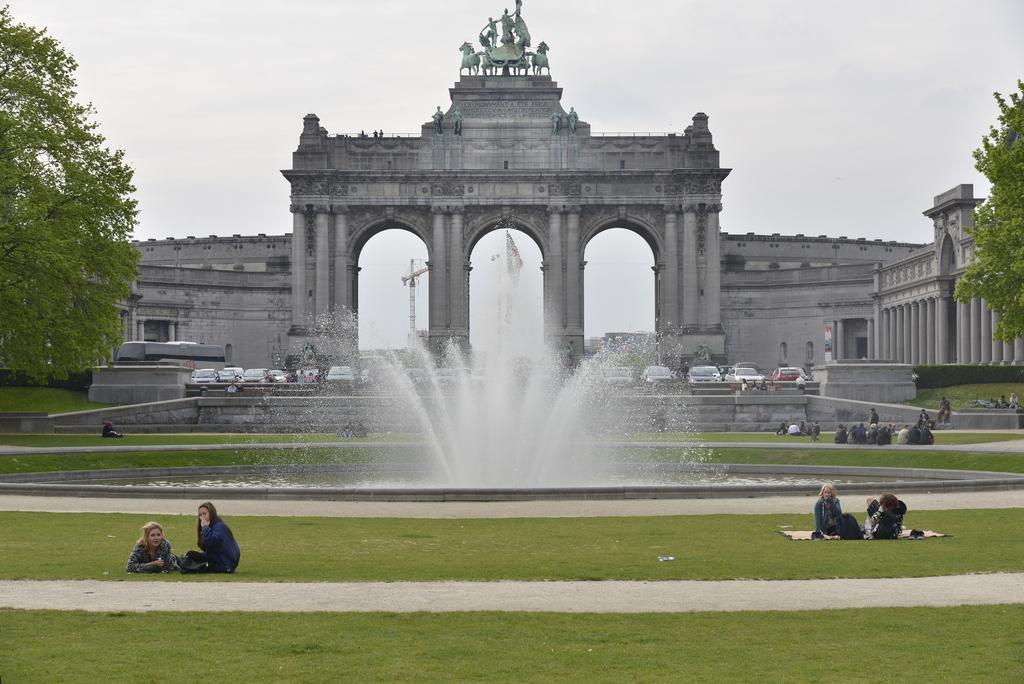In one or two sentences, can you explain what this image depicts? In this image we can see a fountain. Behind cars are parked and monument is present. To the both sides of the image trees are there. Bottom of the image grassy land is there and people are sitting on it. 